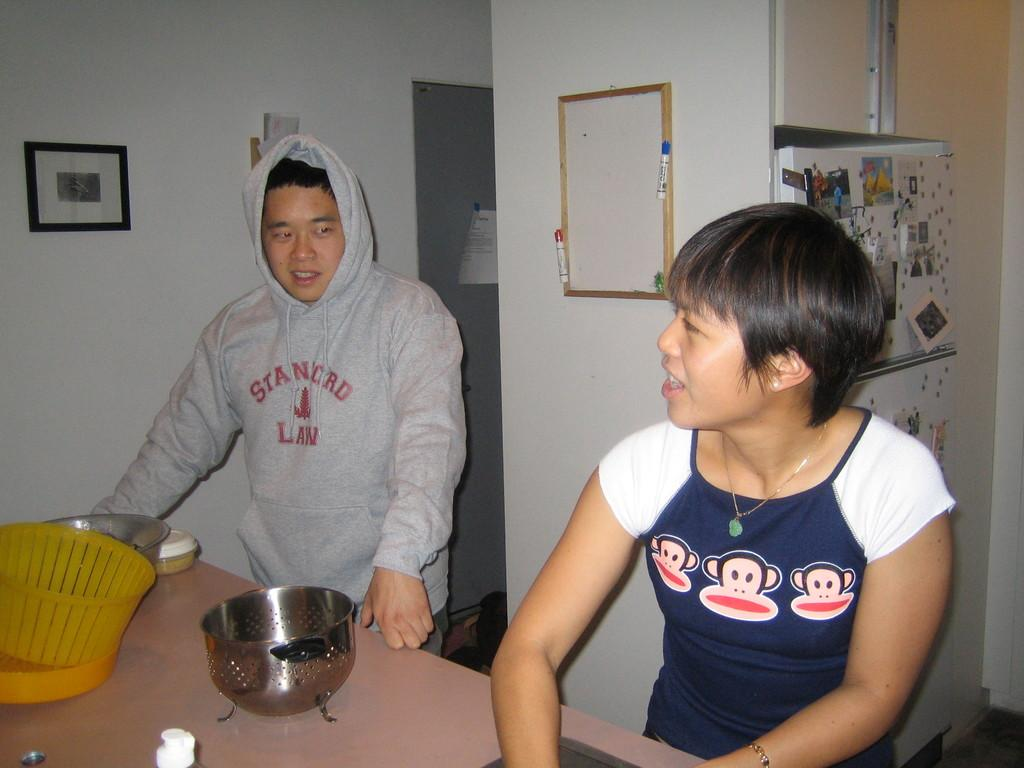How many people are present in the image? There are two persons in the image. What can be seen on the table in the image? There are bowls and objects on the table. What is visible on the wall in the background? There is a frame on the wall in the background. What is present on the refrigerator in the background? There are photos on the refrigerator in the background. How many babies are crawling on the floor in the image? There are no babies present in the image, and no one is crawling on the floor. 